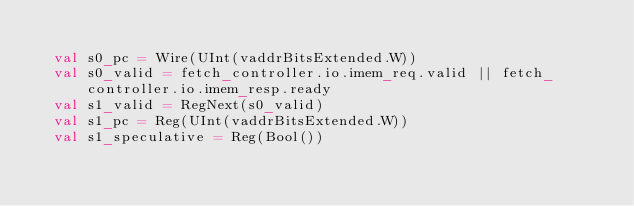<code> <loc_0><loc_0><loc_500><loc_500><_Scala_>
  val s0_pc = Wire(UInt(vaddrBitsExtended.W))
  val s0_valid = fetch_controller.io.imem_req.valid || fetch_controller.io.imem_resp.ready
  val s1_valid = RegNext(s0_valid)
  val s1_pc = Reg(UInt(vaddrBitsExtended.W))
  val s1_speculative = Reg(Bool())</code> 